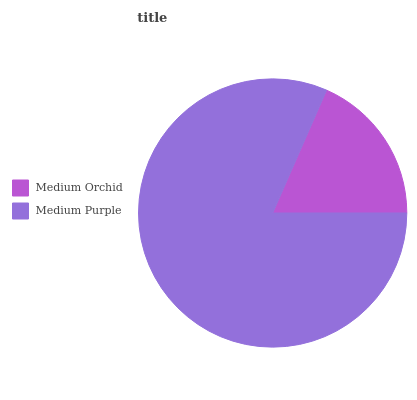Is Medium Orchid the minimum?
Answer yes or no. Yes. Is Medium Purple the maximum?
Answer yes or no. Yes. Is Medium Purple the minimum?
Answer yes or no. No. Is Medium Purple greater than Medium Orchid?
Answer yes or no. Yes. Is Medium Orchid less than Medium Purple?
Answer yes or no. Yes. Is Medium Orchid greater than Medium Purple?
Answer yes or no. No. Is Medium Purple less than Medium Orchid?
Answer yes or no. No. Is Medium Purple the high median?
Answer yes or no. Yes. Is Medium Orchid the low median?
Answer yes or no. Yes. Is Medium Orchid the high median?
Answer yes or no. No. Is Medium Purple the low median?
Answer yes or no. No. 